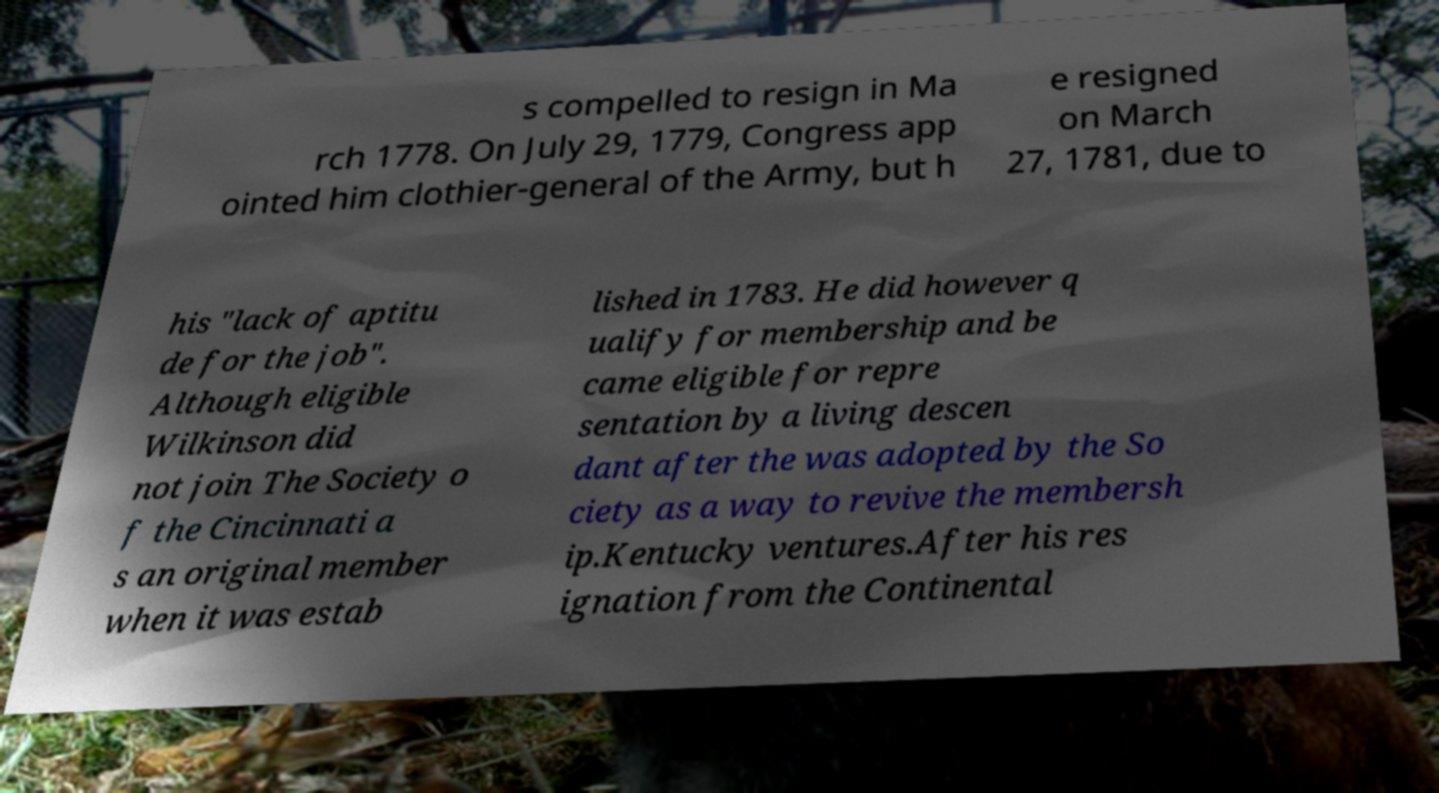I need the written content from this picture converted into text. Can you do that? s compelled to resign in Ma rch 1778. On July 29, 1779, Congress app ointed him clothier-general of the Army, but h e resigned on March 27, 1781, due to his "lack of aptitu de for the job". Although eligible Wilkinson did not join The Society o f the Cincinnati a s an original member when it was estab lished in 1783. He did however q ualify for membership and be came eligible for repre sentation by a living descen dant after the was adopted by the So ciety as a way to revive the membersh ip.Kentucky ventures.After his res ignation from the Continental 